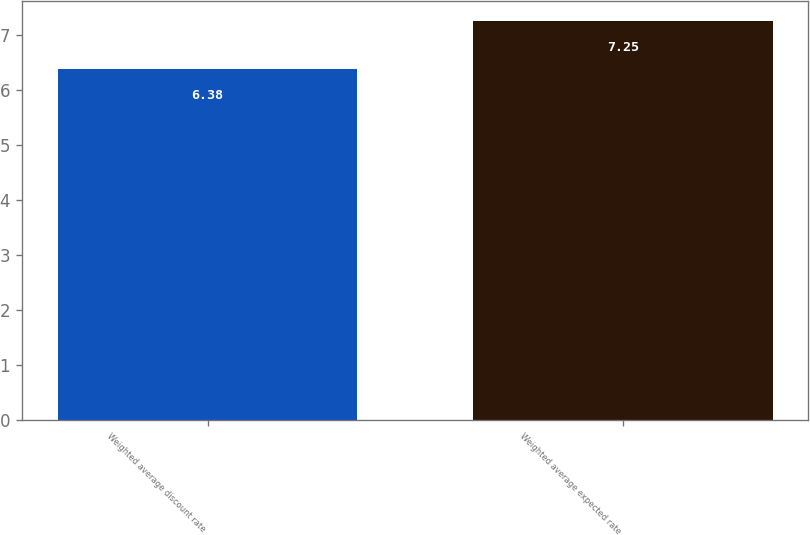<chart> <loc_0><loc_0><loc_500><loc_500><bar_chart><fcel>Weighted average discount rate<fcel>Weighted average expected rate<nl><fcel>6.38<fcel>7.25<nl></chart> 